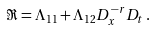<formula> <loc_0><loc_0><loc_500><loc_500>\Re = \Lambda _ { 1 1 } + \Lambda _ { 1 2 } D _ { x } ^ { - r } D _ { t } \, .</formula> 